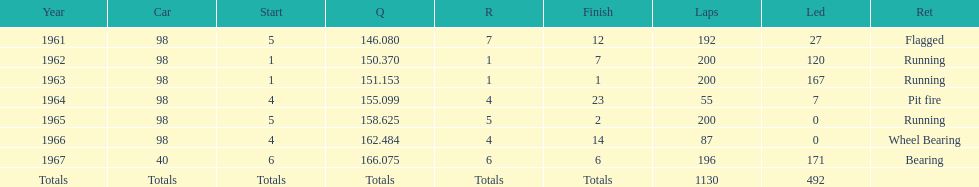What was his best finish before his first win? 7. 